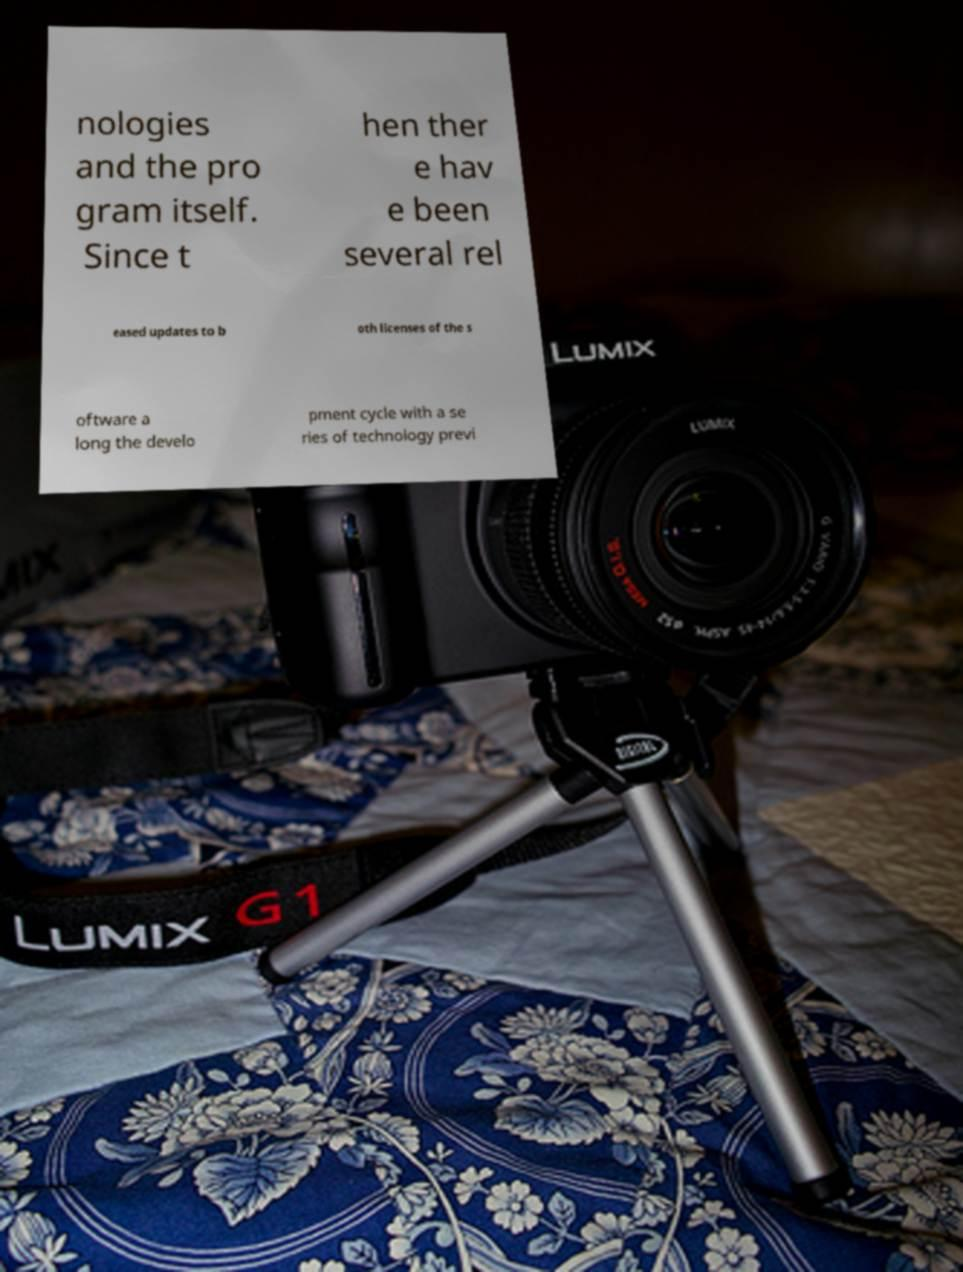Please identify and transcribe the text found in this image. nologies and the pro gram itself. Since t hen ther e hav e been several rel eased updates to b oth licenses of the s oftware a long the develo pment cycle with a se ries of technology previ 